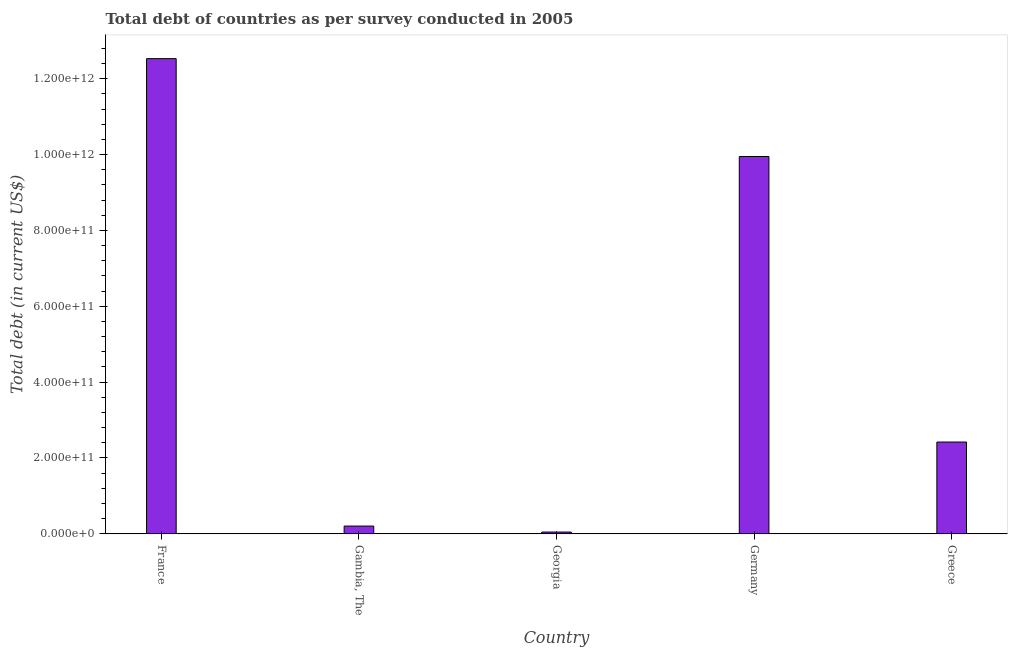Does the graph contain grids?
Your response must be concise. No. What is the title of the graph?
Offer a terse response. Total debt of countries as per survey conducted in 2005. What is the label or title of the Y-axis?
Your response must be concise. Total debt (in current US$). What is the total debt in France?
Keep it short and to the point. 1.25e+12. Across all countries, what is the maximum total debt?
Your response must be concise. 1.25e+12. Across all countries, what is the minimum total debt?
Your answer should be compact. 4.76e+09. In which country was the total debt maximum?
Ensure brevity in your answer.  France. In which country was the total debt minimum?
Make the answer very short. Georgia. What is the sum of the total debt?
Your response must be concise. 2.52e+12. What is the difference between the total debt in Germany and Greece?
Your answer should be compact. 7.53e+11. What is the average total debt per country?
Offer a very short reply. 5.03e+11. What is the median total debt?
Make the answer very short. 2.42e+11. In how many countries, is the total debt greater than 280000000000 US$?
Keep it short and to the point. 2. What is the ratio of the total debt in Gambia, The to that in Greece?
Keep it short and to the point. 0.09. What is the difference between the highest and the second highest total debt?
Make the answer very short. 2.58e+11. Is the sum of the total debt in Germany and Greece greater than the maximum total debt across all countries?
Provide a short and direct response. No. What is the difference between the highest and the lowest total debt?
Your answer should be very brief. 1.25e+12. Are all the bars in the graph horizontal?
Your response must be concise. No. What is the difference between two consecutive major ticks on the Y-axis?
Ensure brevity in your answer.  2.00e+11. Are the values on the major ticks of Y-axis written in scientific E-notation?
Provide a succinct answer. Yes. What is the Total debt (in current US$) of France?
Your answer should be compact. 1.25e+12. What is the Total debt (in current US$) in Gambia, The?
Provide a short and direct response. 2.06e+1. What is the Total debt (in current US$) in Georgia?
Give a very brief answer. 4.76e+09. What is the Total debt (in current US$) of Germany?
Offer a very short reply. 9.95e+11. What is the Total debt (in current US$) of Greece?
Your answer should be very brief. 2.42e+11. What is the difference between the Total debt (in current US$) in France and Gambia, The?
Provide a succinct answer. 1.23e+12. What is the difference between the Total debt (in current US$) in France and Georgia?
Keep it short and to the point. 1.25e+12. What is the difference between the Total debt (in current US$) in France and Germany?
Offer a terse response. 2.58e+11. What is the difference between the Total debt (in current US$) in France and Greece?
Give a very brief answer. 1.01e+12. What is the difference between the Total debt (in current US$) in Gambia, The and Georgia?
Ensure brevity in your answer.  1.58e+1. What is the difference between the Total debt (in current US$) in Gambia, The and Germany?
Give a very brief answer. -9.74e+11. What is the difference between the Total debt (in current US$) in Gambia, The and Greece?
Give a very brief answer. -2.22e+11. What is the difference between the Total debt (in current US$) in Georgia and Germany?
Provide a succinct answer. -9.90e+11. What is the difference between the Total debt (in current US$) in Georgia and Greece?
Your response must be concise. -2.37e+11. What is the difference between the Total debt (in current US$) in Germany and Greece?
Offer a terse response. 7.53e+11. What is the ratio of the Total debt (in current US$) in France to that in Gambia, The?
Your answer should be very brief. 60.9. What is the ratio of the Total debt (in current US$) in France to that in Georgia?
Keep it short and to the point. 263.45. What is the ratio of the Total debt (in current US$) in France to that in Germany?
Keep it short and to the point. 1.26. What is the ratio of the Total debt (in current US$) in France to that in Greece?
Ensure brevity in your answer.  5.17. What is the ratio of the Total debt (in current US$) in Gambia, The to that in Georgia?
Your response must be concise. 4.33. What is the ratio of the Total debt (in current US$) in Gambia, The to that in Germany?
Ensure brevity in your answer.  0.02. What is the ratio of the Total debt (in current US$) in Gambia, The to that in Greece?
Your response must be concise. 0.09. What is the ratio of the Total debt (in current US$) in Georgia to that in Germany?
Provide a short and direct response. 0.01. What is the ratio of the Total debt (in current US$) in Germany to that in Greece?
Offer a terse response. 4.11. 